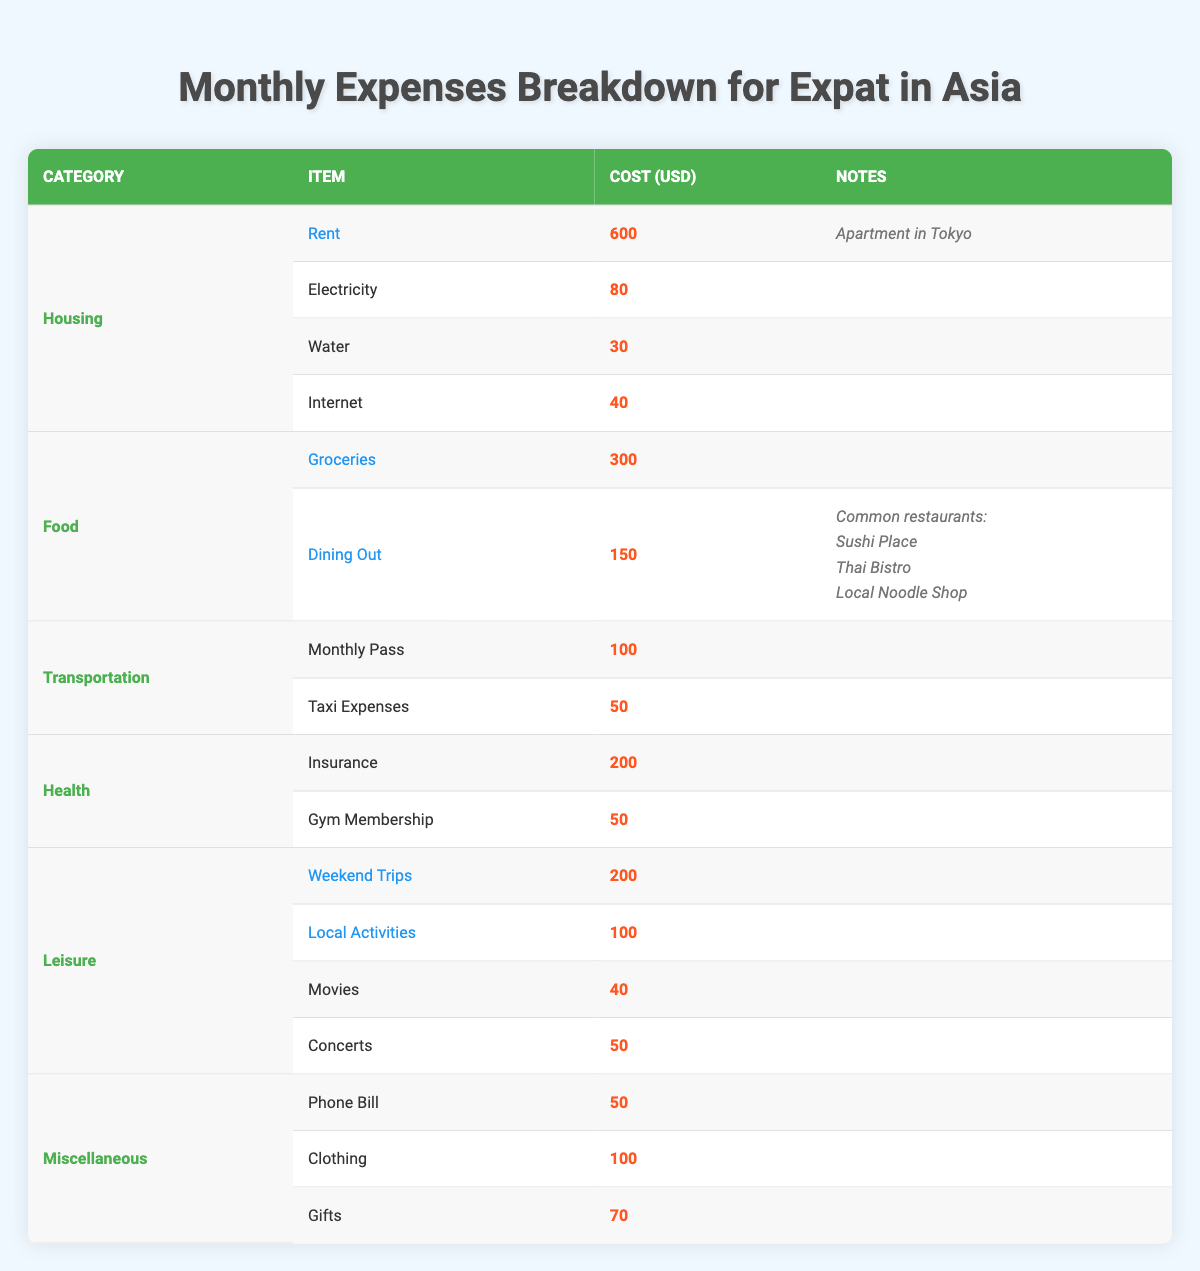What is the total cost for utilities? The utility costs are electricity, water, and internet, which are 80, 30, and 40 respectively. Adding these gives 80 + 30 + 40 = 150.
Answer: 150 What is the cost of dining out per month? The dining out cost is specified as an average cost of 150.
Answer: 150 Is the total cost for leisure-related expenses higher than that for health expenses? The total cost for leisure is the sum of weekend trips (200), local activities (100), movies (40), and concerts (50), which is 200 + 100 + 40 + 50 = 390. The total cost for health is insurance (200) and gym membership (50), which is 200 + 50 = 250. Since 390 is greater than 250, the answer is yes.
Answer: Yes How much is spent on miscellaneous expenses compared to food expenses? The total for miscellaneous expenses is phone bill (50), clothing (100), and gifts (70), resulting in 50 + 100 + 70 = 220. The food expenses total groceries (300) and dining out (150), which equals 300 + 150 = 450. Thus, 220 is less than 450.
Answer: Miscellaneous expenses are less What is the average monthly expense for transportation? The transportation costs are the monthly pass (100) and taxi expenses (50), summing to 100 + 50 = 150. The average is then calculated as 150 divided by 2 (since there are two items), resulting in 75.
Answer: 75 What is the total monthly expenditure on health insurance and gym membership? The health expenses are composed of insurance (200) and gym membership (50). Adding these together gives 200 + 50 = 250.
Answer: 250 Are the weekly trips more expensive than the phone bill? The cost for weekend trips is 200 while the phone bill is 50. Since 200 is greater than 50, the answer is yes.
Answer: Yes What percentage of the total monthly expenses is spent on food? First, we find the total expenses across all categories which are: housing (600 + 80 + 30 + 40 = 750), food (300 + 150 = 450), transportation (100 + 50 = 150), health (200 + 50 = 250), leisure (200 + 100 + 40 + 50 = 390), and miscellaneous (50 + 100 + 70 = 220). Summing all categories gives 750 + 450 + 150 + 250 + 390 + 220 = 2210. The food expense is 450. The percentage is then calculated as (450 / 2210) * 100 = about 20.36%.
Answer: 20.36% What is the highest expense category in the breakdown? By reviewing the data, the highest expense category is housing at a total of 750. The second highest is leisure at 390. Thus, housing is the highest category.
Answer: Housing 